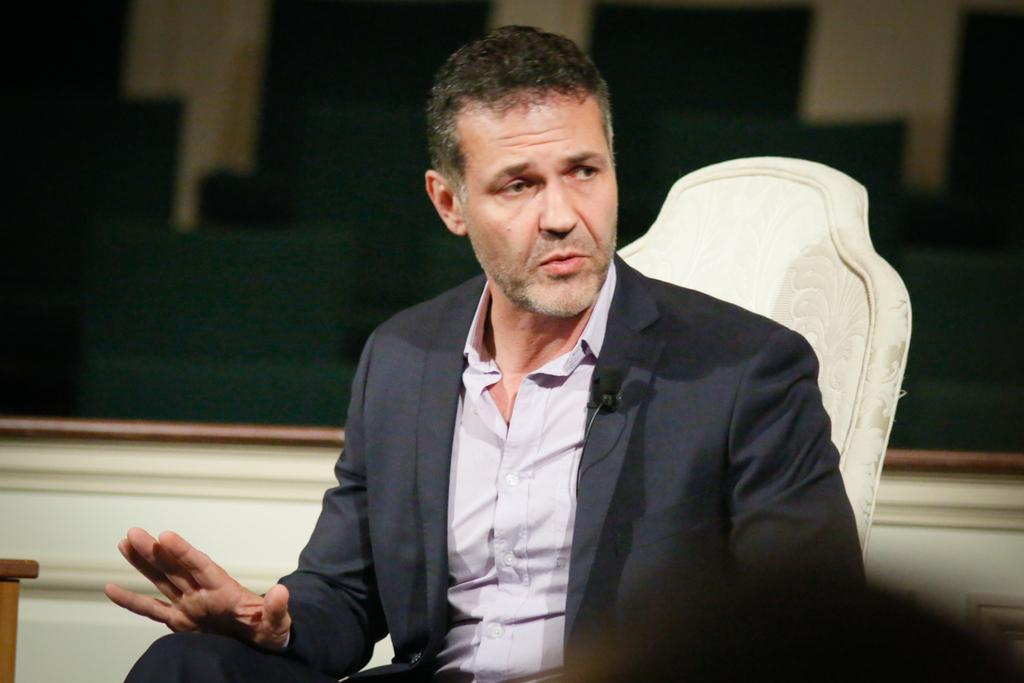What is present in the image that serves as a background? There is a wall in the image that serves as a background. Who is present in the image? There is a man in the image. What is the man wearing? The man is wearing a black jacket. What is the man doing in the image? The man is sitting on a chair. How many pies are being distributed by the man in the image? There are no pies present in the image, nor is the man distributing anything. What type of stone is visible in the image? There is no stone visible in the image. 